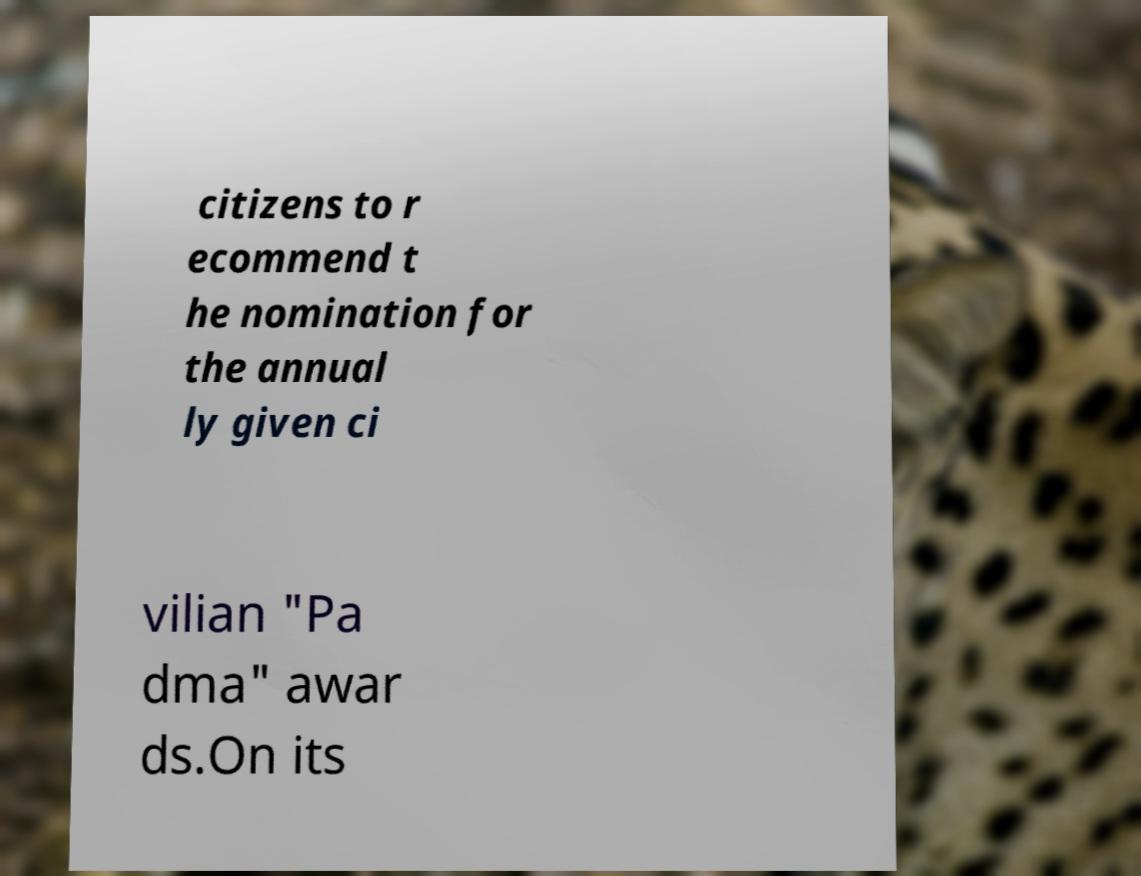Could you assist in decoding the text presented in this image and type it out clearly? citizens to r ecommend t he nomination for the annual ly given ci vilian "Pa dma" awar ds.On its 